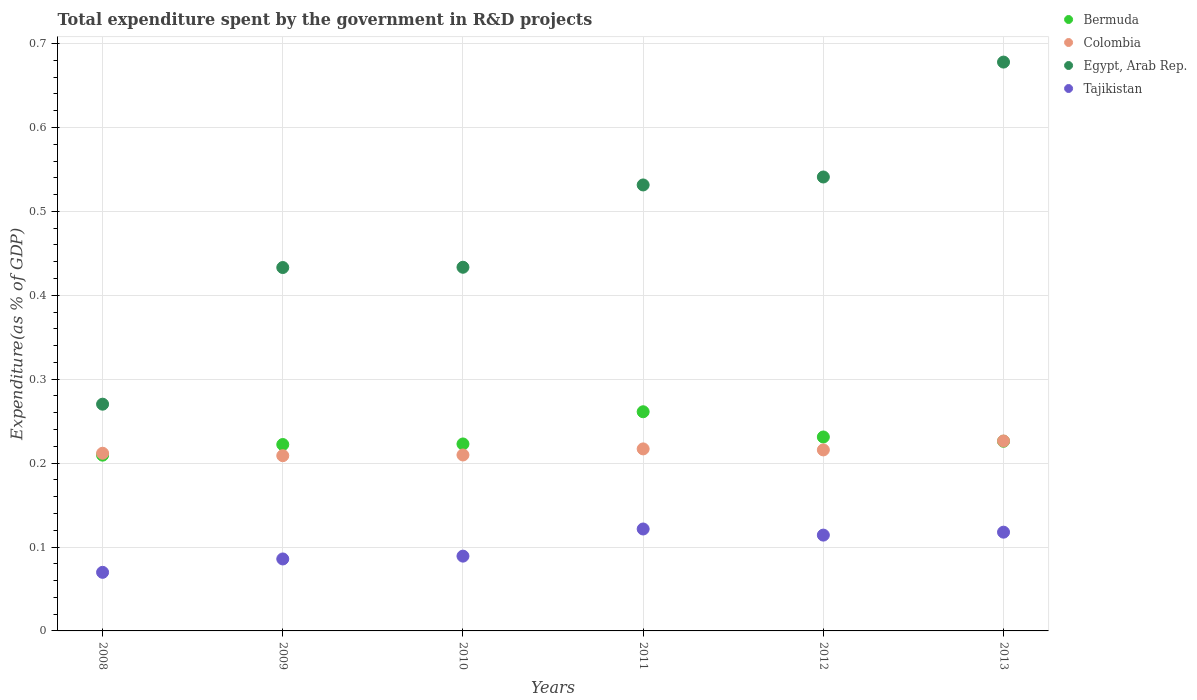What is the total expenditure spent by the government in R&D projects in Tajikistan in 2009?
Give a very brief answer. 0.09. Across all years, what is the maximum total expenditure spent by the government in R&D projects in Egypt, Arab Rep.?
Ensure brevity in your answer.  0.68. Across all years, what is the minimum total expenditure spent by the government in R&D projects in Colombia?
Provide a short and direct response. 0.21. In which year was the total expenditure spent by the government in R&D projects in Tajikistan minimum?
Keep it short and to the point. 2008. What is the total total expenditure spent by the government in R&D projects in Bermuda in the graph?
Keep it short and to the point. 1.37. What is the difference between the total expenditure spent by the government in R&D projects in Tajikistan in 2010 and that in 2011?
Your answer should be very brief. -0.03. What is the difference between the total expenditure spent by the government in R&D projects in Egypt, Arab Rep. in 2010 and the total expenditure spent by the government in R&D projects in Colombia in 2012?
Ensure brevity in your answer.  0.22. What is the average total expenditure spent by the government in R&D projects in Egypt, Arab Rep. per year?
Offer a terse response. 0.48. In the year 2008, what is the difference between the total expenditure spent by the government in R&D projects in Colombia and total expenditure spent by the government in R&D projects in Egypt, Arab Rep.?
Offer a very short reply. -0.06. What is the ratio of the total expenditure spent by the government in R&D projects in Tajikistan in 2011 to that in 2013?
Give a very brief answer. 1.03. Is the difference between the total expenditure spent by the government in R&D projects in Colombia in 2011 and 2013 greater than the difference between the total expenditure spent by the government in R&D projects in Egypt, Arab Rep. in 2011 and 2013?
Give a very brief answer. Yes. What is the difference between the highest and the second highest total expenditure spent by the government in R&D projects in Tajikistan?
Provide a succinct answer. 0. What is the difference between the highest and the lowest total expenditure spent by the government in R&D projects in Bermuda?
Ensure brevity in your answer.  0.05. Is it the case that in every year, the sum of the total expenditure spent by the government in R&D projects in Bermuda and total expenditure spent by the government in R&D projects in Egypt, Arab Rep.  is greater than the sum of total expenditure spent by the government in R&D projects in Tajikistan and total expenditure spent by the government in R&D projects in Colombia?
Offer a terse response. No. Is it the case that in every year, the sum of the total expenditure spent by the government in R&D projects in Colombia and total expenditure spent by the government in R&D projects in Bermuda  is greater than the total expenditure spent by the government in R&D projects in Tajikistan?
Offer a very short reply. Yes. Is the total expenditure spent by the government in R&D projects in Egypt, Arab Rep. strictly greater than the total expenditure spent by the government in R&D projects in Tajikistan over the years?
Your response must be concise. Yes. How many dotlines are there?
Make the answer very short. 4. What is the difference between two consecutive major ticks on the Y-axis?
Your answer should be very brief. 0.1. Are the values on the major ticks of Y-axis written in scientific E-notation?
Your response must be concise. No. Does the graph contain any zero values?
Make the answer very short. No. Where does the legend appear in the graph?
Keep it short and to the point. Top right. How many legend labels are there?
Offer a very short reply. 4. What is the title of the graph?
Provide a succinct answer. Total expenditure spent by the government in R&D projects. What is the label or title of the Y-axis?
Your response must be concise. Expenditure(as % of GDP). What is the Expenditure(as % of GDP) in Bermuda in 2008?
Your response must be concise. 0.21. What is the Expenditure(as % of GDP) in Colombia in 2008?
Offer a very short reply. 0.21. What is the Expenditure(as % of GDP) in Egypt, Arab Rep. in 2008?
Keep it short and to the point. 0.27. What is the Expenditure(as % of GDP) in Tajikistan in 2008?
Your answer should be compact. 0.07. What is the Expenditure(as % of GDP) in Bermuda in 2009?
Offer a terse response. 0.22. What is the Expenditure(as % of GDP) of Colombia in 2009?
Offer a terse response. 0.21. What is the Expenditure(as % of GDP) of Egypt, Arab Rep. in 2009?
Give a very brief answer. 0.43. What is the Expenditure(as % of GDP) of Tajikistan in 2009?
Keep it short and to the point. 0.09. What is the Expenditure(as % of GDP) in Bermuda in 2010?
Offer a terse response. 0.22. What is the Expenditure(as % of GDP) of Colombia in 2010?
Ensure brevity in your answer.  0.21. What is the Expenditure(as % of GDP) of Egypt, Arab Rep. in 2010?
Give a very brief answer. 0.43. What is the Expenditure(as % of GDP) in Tajikistan in 2010?
Offer a terse response. 0.09. What is the Expenditure(as % of GDP) of Bermuda in 2011?
Your answer should be compact. 0.26. What is the Expenditure(as % of GDP) of Colombia in 2011?
Provide a short and direct response. 0.22. What is the Expenditure(as % of GDP) in Egypt, Arab Rep. in 2011?
Make the answer very short. 0.53. What is the Expenditure(as % of GDP) of Tajikistan in 2011?
Give a very brief answer. 0.12. What is the Expenditure(as % of GDP) of Bermuda in 2012?
Offer a very short reply. 0.23. What is the Expenditure(as % of GDP) in Colombia in 2012?
Ensure brevity in your answer.  0.22. What is the Expenditure(as % of GDP) in Egypt, Arab Rep. in 2012?
Your response must be concise. 0.54. What is the Expenditure(as % of GDP) in Tajikistan in 2012?
Ensure brevity in your answer.  0.11. What is the Expenditure(as % of GDP) of Bermuda in 2013?
Give a very brief answer. 0.23. What is the Expenditure(as % of GDP) in Colombia in 2013?
Your response must be concise. 0.23. What is the Expenditure(as % of GDP) of Egypt, Arab Rep. in 2013?
Your response must be concise. 0.68. What is the Expenditure(as % of GDP) in Tajikistan in 2013?
Keep it short and to the point. 0.12. Across all years, what is the maximum Expenditure(as % of GDP) in Bermuda?
Ensure brevity in your answer.  0.26. Across all years, what is the maximum Expenditure(as % of GDP) in Colombia?
Your response must be concise. 0.23. Across all years, what is the maximum Expenditure(as % of GDP) in Egypt, Arab Rep.?
Offer a very short reply. 0.68. Across all years, what is the maximum Expenditure(as % of GDP) in Tajikistan?
Your answer should be compact. 0.12. Across all years, what is the minimum Expenditure(as % of GDP) of Bermuda?
Offer a terse response. 0.21. Across all years, what is the minimum Expenditure(as % of GDP) of Colombia?
Make the answer very short. 0.21. Across all years, what is the minimum Expenditure(as % of GDP) in Egypt, Arab Rep.?
Offer a terse response. 0.27. Across all years, what is the minimum Expenditure(as % of GDP) in Tajikistan?
Give a very brief answer. 0.07. What is the total Expenditure(as % of GDP) of Bermuda in the graph?
Ensure brevity in your answer.  1.37. What is the total Expenditure(as % of GDP) of Colombia in the graph?
Give a very brief answer. 1.29. What is the total Expenditure(as % of GDP) of Egypt, Arab Rep. in the graph?
Provide a succinct answer. 2.89. What is the total Expenditure(as % of GDP) in Tajikistan in the graph?
Make the answer very short. 0.6. What is the difference between the Expenditure(as % of GDP) of Bermuda in 2008 and that in 2009?
Provide a succinct answer. -0.01. What is the difference between the Expenditure(as % of GDP) in Colombia in 2008 and that in 2009?
Your answer should be very brief. 0. What is the difference between the Expenditure(as % of GDP) of Egypt, Arab Rep. in 2008 and that in 2009?
Your answer should be very brief. -0.16. What is the difference between the Expenditure(as % of GDP) in Tajikistan in 2008 and that in 2009?
Make the answer very short. -0.02. What is the difference between the Expenditure(as % of GDP) of Bermuda in 2008 and that in 2010?
Offer a very short reply. -0.01. What is the difference between the Expenditure(as % of GDP) of Colombia in 2008 and that in 2010?
Your answer should be compact. 0. What is the difference between the Expenditure(as % of GDP) of Egypt, Arab Rep. in 2008 and that in 2010?
Offer a very short reply. -0.16. What is the difference between the Expenditure(as % of GDP) of Tajikistan in 2008 and that in 2010?
Make the answer very short. -0.02. What is the difference between the Expenditure(as % of GDP) in Bermuda in 2008 and that in 2011?
Offer a very short reply. -0.05. What is the difference between the Expenditure(as % of GDP) in Colombia in 2008 and that in 2011?
Offer a terse response. -0.01. What is the difference between the Expenditure(as % of GDP) in Egypt, Arab Rep. in 2008 and that in 2011?
Your answer should be compact. -0.26. What is the difference between the Expenditure(as % of GDP) of Tajikistan in 2008 and that in 2011?
Make the answer very short. -0.05. What is the difference between the Expenditure(as % of GDP) in Bermuda in 2008 and that in 2012?
Provide a succinct answer. -0.02. What is the difference between the Expenditure(as % of GDP) of Colombia in 2008 and that in 2012?
Your answer should be compact. -0. What is the difference between the Expenditure(as % of GDP) of Egypt, Arab Rep. in 2008 and that in 2012?
Provide a succinct answer. -0.27. What is the difference between the Expenditure(as % of GDP) in Tajikistan in 2008 and that in 2012?
Give a very brief answer. -0.04. What is the difference between the Expenditure(as % of GDP) of Bermuda in 2008 and that in 2013?
Your answer should be very brief. -0.02. What is the difference between the Expenditure(as % of GDP) of Colombia in 2008 and that in 2013?
Your answer should be compact. -0.01. What is the difference between the Expenditure(as % of GDP) in Egypt, Arab Rep. in 2008 and that in 2013?
Provide a short and direct response. -0.41. What is the difference between the Expenditure(as % of GDP) in Tajikistan in 2008 and that in 2013?
Provide a succinct answer. -0.05. What is the difference between the Expenditure(as % of GDP) in Bermuda in 2009 and that in 2010?
Offer a terse response. -0. What is the difference between the Expenditure(as % of GDP) in Colombia in 2009 and that in 2010?
Ensure brevity in your answer.  -0. What is the difference between the Expenditure(as % of GDP) in Egypt, Arab Rep. in 2009 and that in 2010?
Make the answer very short. -0. What is the difference between the Expenditure(as % of GDP) in Tajikistan in 2009 and that in 2010?
Keep it short and to the point. -0. What is the difference between the Expenditure(as % of GDP) of Bermuda in 2009 and that in 2011?
Give a very brief answer. -0.04. What is the difference between the Expenditure(as % of GDP) in Colombia in 2009 and that in 2011?
Ensure brevity in your answer.  -0.01. What is the difference between the Expenditure(as % of GDP) in Egypt, Arab Rep. in 2009 and that in 2011?
Make the answer very short. -0.1. What is the difference between the Expenditure(as % of GDP) of Tajikistan in 2009 and that in 2011?
Keep it short and to the point. -0.04. What is the difference between the Expenditure(as % of GDP) in Bermuda in 2009 and that in 2012?
Your answer should be very brief. -0.01. What is the difference between the Expenditure(as % of GDP) of Colombia in 2009 and that in 2012?
Offer a very short reply. -0.01. What is the difference between the Expenditure(as % of GDP) in Egypt, Arab Rep. in 2009 and that in 2012?
Offer a very short reply. -0.11. What is the difference between the Expenditure(as % of GDP) of Tajikistan in 2009 and that in 2012?
Keep it short and to the point. -0.03. What is the difference between the Expenditure(as % of GDP) in Bermuda in 2009 and that in 2013?
Your answer should be compact. -0. What is the difference between the Expenditure(as % of GDP) in Colombia in 2009 and that in 2013?
Your answer should be compact. -0.02. What is the difference between the Expenditure(as % of GDP) of Egypt, Arab Rep. in 2009 and that in 2013?
Make the answer very short. -0.24. What is the difference between the Expenditure(as % of GDP) of Tajikistan in 2009 and that in 2013?
Provide a short and direct response. -0.03. What is the difference between the Expenditure(as % of GDP) of Bermuda in 2010 and that in 2011?
Provide a succinct answer. -0.04. What is the difference between the Expenditure(as % of GDP) in Colombia in 2010 and that in 2011?
Ensure brevity in your answer.  -0.01. What is the difference between the Expenditure(as % of GDP) in Egypt, Arab Rep. in 2010 and that in 2011?
Your answer should be compact. -0.1. What is the difference between the Expenditure(as % of GDP) in Tajikistan in 2010 and that in 2011?
Give a very brief answer. -0.03. What is the difference between the Expenditure(as % of GDP) of Bermuda in 2010 and that in 2012?
Your answer should be very brief. -0.01. What is the difference between the Expenditure(as % of GDP) in Colombia in 2010 and that in 2012?
Your answer should be very brief. -0.01. What is the difference between the Expenditure(as % of GDP) in Egypt, Arab Rep. in 2010 and that in 2012?
Your answer should be compact. -0.11. What is the difference between the Expenditure(as % of GDP) in Tajikistan in 2010 and that in 2012?
Offer a terse response. -0.03. What is the difference between the Expenditure(as % of GDP) of Bermuda in 2010 and that in 2013?
Make the answer very short. -0. What is the difference between the Expenditure(as % of GDP) in Colombia in 2010 and that in 2013?
Give a very brief answer. -0.02. What is the difference between the Expenditure(as % of GDP) of Egypt, Arab Rep. in 2010 and that in 2013?
Offer a terse response. -0.24. What is the difference between the Expenditure(as % of GDP) of Tajikistan in 2010 and that in 2013?
Provide a succinct answer. -0.03. What is the difference between the Expenditure(as % of GDP) in Bermuda in 2011 and that in 2012?
Give a very brief answer. 0.03. What is the difference between the Expenditure(as % of GDP) of Colombia in 2011 and that in 2012?
Make the answer very short. 0. What is the difference between the Expenditure(as % of GDP) in Egypt, Arab Rep. in 2011 and that in 2012?
Provide a succinct answer. -0.01. What is the difference between the Expenditure(as % of GDP) in Tajikistan in 2011 and that in 2012?
Your response must be concise. 0.01. What is the difference between the Expenditure(as % of GDP) of Bermuda in 2011 and that in 2013?
Provide a succinct answer. 0.04. What is the difference between the Expenditure(as % of GDP) of Colombia in 2011 and that in 2013?
Keep it short and to the point. -0.01. What is the difference between the Expenditure(as % of GDP) of Egypt, Arab Rep. in 2011 and that in 2013?
Give a very brief answer. -0.15. What is the difference between the Expenditure(as % of GDP) in Tajikistan in 2011 and that in 2013?
Provide a succinct answer. 0. What is the difference between the Expenditure(as % of GDP) of Bermuda in 2012 and that in 2013?
Your response must be concise. 0.01. What is the difference between the Expenditure(as % of GDP) of Colombia in 2012 and that in 2013?
Your answer should be compact. -0.01. What is the difference between the Expenditure(as % of GDP) in Egypt, Arab Rep. in 2012 and that in 2013?
Offer a terse response. -0.14. What is the difference between the Expenditure(as % of GDP) in Tajikistan in 2012 and that in 2013?
Give a very brief answer. -0. What is the difference between the Expenditure(as % of GDP) in Bermuda in 2008 and the Expenditure(as % of GDP) in Colombia in 2009?
Offer a terse response. 0. What is the difference between the Expenditure(as % of GDP) of Bermuda in 2008 and the Expenditure(as % of GDP) of Egypt, Arab Rep. in 2009?
Provide a succinct answer. -0.22. What is the difference between the Expenditure(as % of GDP) of Bermuda in 2008 and the Expenditure(as % of GDP) of Tajikistan in 2009?
Offer a terse response. 0.12. What is the difference between the Expenditure(as % of GDP) of Colombia in 2008 and the Expenditure(as % of GDP) of Egypt, Arab Rep. in 2009?
Keep it short and to the point. -0.22. What is the difference between the Expenditure(as % of GDP) of Colombia in 2008 and the Expenditure(as % of GDP) of Tajikistan in 2009?
Ensure brevity in your answer.  0.13. What is the difference between the Expenditure(as % of GDP) of Egypt, Arab Rep. in 2008 and the Expenditure(as % of GDP) of Tajikistan in 2009?
Your answer should be very brief. 0.18. What is the difference between the Expenditure(as % of GDP) of Bermuda in 2008 and the Expenditure(as % of GDP) of Colombia in 2010?
Make the answer very short. -0. What is the difference between the Expenditure(as % of GDP) in Bermuda in 2008 and the Expenditure(as % of GDP) in Egypt, Arab Rep. in 2010?
Your response must be concise. -0.22. What is the difference between the Expenditure(as % of GDP) of Bermuda in 2008 and the Expenditure(as % of GDP) of Tajikistan in 2010?
Provide a succinct answer. 0.12. What is the difference between the Expenditure(as % of GDP) of Colombia in 2008 and the Expenditure(as % of GDP) of Egypt, Arab Rep. in 2010?
Keep it short and to the point. -0.22. What is the difference between the Expenditure(as % of GDP) in Colombia in 2008 and the Expenditure(as % of GDP) in Tajikistan in 2010?
Provide a succinct answer. 0.12. What is the difference between the Expenditure(as % of GDP) in Egypt, Arab Rep. in 2008 and the Expenditure(as % of GDP) in Tajikistan in 2010?
Offer a very short reply. 0.18. What is the difference between the Expenditure(as % of GDP) in Bermuda in 2008 and the Expenditure(as % of GDP) in Colombia in 2011?
Ensure brevity in your answer.  -0.01. What is the difference between the Expenditure(as % of GDP) in Bermuda in 2008 and the Expenditure(as % of GDP) in Egypt, Arab Rep. in 2011?
Your response must be concise. -0.32. What is the difference between the Expenditure(as % of GDP) of Bermuda in 2008 and the Expenditure(as % of GDP) of Tajikistan in 2011?
Your response must be concise. 0.09. What is the difference between the Expenditure(as % of GDP) of Colombia in 2008 and the Expenditure(as % of GDP) of Egypt, Arab Rep. in 2011?
Offer a very short reply. -0.32. What is the difference between the Expenditure(as % of GDP) of Colombia in 2008 and the Expenditure(as % of GDP) of Tajikistan in 2011?
Your response must be concise. 0.09. What is the difference between the Expenditure(as % of GDP) of Egypt, Arab Rep. in 2008 and the Expenditure(as % of GDP) of Tajikistan in 2011?
Keep it short and to the point. 0.15. What is the difference between the Expenditure(as % of GDP) in Bermuda in 2008 and the Expenditure(as % of GDP) in Colombia in 2012?
Make the answer very short. -0.01. What is the difference between the Expenditure(as % of GDP) of Bermuda in 2008 and the Expenditure(as % of GDP) of Egypt, Arab Rep. in 2012?
Offer a terse response. -0.33. What is the difference between the Expenditure(as % of GDP) in Bermuda in 2008 and the Expenditure(as % of GDP) in Tajikistan in 2012?
Your answer should be compact. 0.1. What is the difference between the Expenditure(as % of GDP) of Colombia in 2008 and the Expenditure(as % of GDP) of Egypt, Arab Rep. in 2012?
Your response must be concise. -0.33. What is the difference between the Expenditure(as % of GDP) in Colombia in 2008 and the Expenditure(as % of GDP) in Tajikistan in 2012?
Provide a succinct answer. 0.1. What is the difference between the Expenditure(as % of GDP) in Egypt, Arab Rep. in 2008 and the Expenditure(as % of GDP) in Tajikistan in 2012?
Make the answer very short. 0.16. What is the difference between the Expenditure(as % of GDP) in Bermuda in 2008 and the Expenditure(as % of GDP) in Colombia in 2013?
Offer a very short reply. -0.02. What is the difference between the Expenditure(as % of GDP) of Bermuda in 2008 and the Expenditure(as % of GDP) of Egypt, Arab Rep. in 2013?
Give a very brief answer. -0.47. What is the difference between the Expenditure(as % of GDP) in Bermuda in 2008 and the Expenditure(as % of GDP) in Tajikistan in 2013?
Your response must be concise. 0.09. What is the difference between the Expenditure(as % of GDP) of Colombia in 2008 and the Expenditure(as % of GDP) of Egypt, Arab Rep. in 2013?
Your response must be concise. -0.47. What is the difference between the Expenditure(as % of GDP) of Colombia in 2008 and the Expenditure(as % of GDP) of Tajikistan in 2013?
Give a very brief answer. 0.09. What is the difference between the Expenditure(as % of GDP) in Egypt, Arab Rep. in 2008 and the Expenditure(as % of GDP) in Tajikistan in 2013?
Your answer should be very brief. 0.15. What is the difference between the Expenditure(as % of GDP) of Bermuda in 2009 and the Expenditure(as % of GDP) of Colombia in 2010?
Your answer should be very brief. 0.01. What is the difference between the Expenditure(as % of GDP) of Bermuda in 2009 and the Expenditure(as % of GDP) of Egypt, Arab Rep. in 2010?
Give a very brief answer. -0.21. What is the difference between the Expenditure(as % of GDP) of Bermuda in 2009 and the Expenditure(as % of GDP) of Tajikistan in 2010?
Your response must be concise. 0.13. What is the difference between the Expenditure(as % of GDP) of Colombia in 2009 and the Expenditure(as % of GDP) of Egypt, Arab Rep. in 2010?
Offer a terse response. -0.22. What is the difference between the Expenditure(as % of GDP) of Colombia in 2009 and the Expenditure(as % of GDP) of Tajikistan in 2010?
Offer a very short reply. 0.12. What is the difference between the Expenditure(as % of GDP) of Egypt, Arab Rep. in 2009 and the Expenditure(as % of GDP) of Tajikistan in 2010?
Make the answer very short. 0.34. What is the difference between the Expenditure(as % of GDP) in Bermuda in 2009 and the Expenditure(as % of GDP) in Colombia in 2011?
Your answer should be very brief. 0.01. What is the difference between the Expenditure(as % of GDP) of Bermuda in 2009 and the Expenditure(as % of GDP) of Egypt, Arab Rep. in 2011?
Keep it short and to the point. -0.31. What is the difference between the Expenditure(as % of GDP) of Bermuda in 2009 and the Expenditure(as % of GDP) of Tajikistan in 2011?
Ensure brevity in your answer.  0.1. What is the difference between the Expenditure(as % of GDP) in Colombia in 2009 and the Expenditure(as % of GDP) in Egypt, Arab Rep. in 2011?
Keep it short and to the point. -0.32. What is the difference between the Expenditure(as % of GDP) of Colombia in 2009 and the Expenditure(as % of GDP) of Tajikistan in 2011?
Keep it short and to the point. 0.09. What is the difference between the Expenditure(as % of GDP) in Egypt, Arab Rep. in 2009 and the Expenditure(as % of GDP) in Tajikistan in 2011?
Make the answer very short. 0.31. What is the difference between the Expenditure(as % of GDP) of Bermuda in 2009 and the Expenditure(as % of GDP) of Colombia in 2012?
Your answer should be very brief. 0.01. What is the difference between the Expenditure(as % of GDP) in Bermuda in 2009 and the Expenditure(as % of GDP) in Egypt, Arab Rep. in 2012?
Offer a very short reply. -0.32. What is the difference between the Expenditure(as % of GDP) of Bermuda in 2009 and the Expenditure(as % of GDP) of Tajikistan in 2012?
Your answer should be very brief. 0.11. What is the difference between the Expenditure(as % of GDP) in Colombia in 2009 and the Expenditure(as % of GDP) in Egypt, Arab Rep. in 2012?
Provide a short and direct response. -0.33. What is the difference between the Expenditure(as % of GDP) of Colombia in 2009 and the Expenditure(as % of GDP) of Tajikistan in 2012?
Keep it short and to the point. 0.09. What is the difference between the Expenditure(as % of GDP) of Egypt, Arab Rep. in 2009 and the Expenditure(as % of GDP) of Tajikistan in 2012?
Provide a short and direct response. 0.32. What is the difference between the Expenditure(as % of GDP) of Bermuda in 2009 and the Expenditure(as % of GDP) of Colombia in 2013?
Offer a very short reply. -0. What is the difference between the Expenditure(as % of GDP) of Bermuda in 2009 and the Expenditure(as % of GDP) of Egypt, Arab Rep. in 2013?
Keep it short and to the point. -0.46. What is the difference between the Expenditure(as % of GDP) of Bermuda in 2009 and the Expenditure(as % of GDP) of Tajikistan in 2013?
Make the answer very short. 0.1. What is the difference between the Expenditure(as % of GDP) in Colombia in 2009 and the Expenditure(as % of GDP) in Egypt, Arab Rep. in 2013?
Keep it short and to the point. -0.47. What is the difference between the Expenditure(as % of GDP) in Colombia in 2009 and the Expenditure(as % of GDP) in Tajikistan in 2013?
Offer a very short reply. 0.09. What is the difference between the Expenditure(as % of GDP) of Egypt, Arab Rep. in 2009 and the Expenditure(as % of GDP) of Tajikistan in 2013?
Provide a short and direct response. 0.32. What is the difference between the Expenditure(as % of GDP) of Bermuda in 2010 and the Expenditure(as % of GDP) of Colombia in 2011?
Ensure brevity in your answer.  0.01. What is the difference between the Expenditure(as % of GDP) in Bermuda in 2010 and the Expenditure(as % of GDP) in Egypt, Arab Rep. in 2011?
Your answer should be compact. -0.31. What is the difference between the Expenditure(as % of GDP) in Bermuda in 2010 and the Expenditure(as % of GDP) in Tajikistan in 2011?
Offer a very short reply. 0.1. What is the difference between the Expenditure(as % of GDP) in Colombia in 2010 and the Expenditure(as % of GDP) in Egypt, Arab Rep. in 2011?
Provide a short and direct response. -0.32. What is the difference between the Expenditure(as % of GDP) in Colombia in 2010 and the Expenditure(as % of GDP) in Tajikistan in 2011?
Provide a succinct answer. 0.09. What is the difference between the Expenditure(as % of GDP) in Egypt, Arab Rep. in 2010 and the Expenditure(as % of GDP) in Tajikistan in 2011?
Provide a succinct answer. 0.31. What is the difference between the Expenditure(as % of GDP) of Bermuda in 2010 and the Expenditure(as % of GDP) of Colombia in 2012?
Give a very brief answer. 0.01. What is the difference between the Expenditure(as % of GDP) of Bermuda in 2010 and the Expenditure(as % of GDP) of Egypt, Arab Rep. in 2012?
Your answer should be very brief. -0.32. What is the difference between the Expenditure(as % of GDP) in Bermuda in 2010 and the Expenditure(as % of GDP) in Tajikistan in 2012?
Your response must be concise. 0.11. What is the difference between the Expenditure(as % of GDP) in Colombia in 2010 and the Expenditure(as % of GDP) in Egypt, Arab Rep. in 2012?
Keep it short and to the point. -0.33. What is the difference between the Expenditure(as % of GDP) of Colombia in 2010 and the Expenditure(as % of GDP) of Tajikistan in 2012?
Make the answer very short. 0.1. What is the difference between the Expenditure(as % of GDP) of Egypt, Arab Rep. in 2010 and the Expenditure(as % of GDP) of Tajikistan in 2012?
Your answer should be compact. 0.32. What is the difference between the Expenditure(as % of GDP) in Bermuda in 2010 and the Expenditure(as % of GDP) in Colombia in 2013?
Keep it short and to the point. -0. What is the difference between the Expenditure(as % of GDP) of Bermuda in 2010 and the Expenditure(as % of GDP) of Egypt, Arab Rep. in 2013?
Offer a terse response. -0.46. What is the difference between the Expenditure(as % of GDP) of Bermuda in 2010 and the Expenditure(as % of GDP) of Tajikistan in 2013?
Your answer should be compact. 0.11. What is the difference between the Expenditure(as % of GDP) of Colombia in 2010 and the Expenditure(as % of GDP) of Egypt, Arab Rep. in 2013?
Offer a terse response. -0.47. What is the difference between the Expenditure(as % of GDP) in Colombia in 2010 and the Expenditure(as % of GDP) in Tajikistan in 2013?
Offer a terse response. 0.09. What is the difference between the Expenditure(as % of GDP) of Egypt, Arab Rep. in 2010 and the Expenditure(as % of GDP) of Tajikistan in 2013?
Provide a short and direct response. 0.32. What is the difference between the Expenditure(as % of GDP) of Bermuda in 2011 and the Expenditure(as % of GDP) of Colombia in 2012?
Offer a terse response. 0.05. What is the difference between the Expenditure(as % of GDP) in Bermuda in 2011 and the Expenditure(as % of GDP) in Egypt, Arab Rep. in 2012?
Your answer should be compact. -0.28. What is the difference between the Expenditure(as % of GDP) in Bermuda in 2011 and the Expenditure(as % of GDP) in Tajikistan in 2012?
Offer a terse response. 0.15. What is the difference between the Expenditure(as % of GDP) of Colombia in 2011 and the Expenditure(as % of GDP) of Egypt, Arab Rep. in 2012?
Your answer should be compact. -0.32. What is the difference between the Expenditure(as % of GDP) of Colombia in 2011 and the Expenditure(as % of GDP) of Tajikistan in 2012?
Make the answer very short. 0.1. What is the difference between the Expenditure(as % of GDP) in Egypt, Arab Rep. in 2011 and the Expenditure(as % of GDP) in Tajikistan in 2012?
Provide a short and direct response. 0.42. What is the difference between the Expenditure(as % of GDP) of Bermuda in 2011 and the Expenditure(as % of GDP) of Colombia in 2013?
Ensure brevity in your answer.  0.03. What is the difference between the Expenditure(as % of GDP) in Bermuda in 2011 and the Expenditure(as % of GDP) in Egypt, Arab Rep. in 2013?
Ensure brevity in your answer.  -0.42. What is the difference between the Expenditure(as % of GDP) of Bermuda in 2011 and the Expenditure(as % of GDP) of Tajikistan in 2013?
Give a very brief answer. 0.14. What is the difference between the Expenditure(as % of GDP) in Colombia in 2011 and the Expenditure(as % of GDP) in Egypt, Arab Rep. in 2013?
Provide a short and direct response. -0.46. What is the difference between the Expenditure(as % of GDP) of Colombia in 2011 and the Expenditure(as % of GDP) of Tajikistan in 2013?
Your answer should be very brief. 0.1. What is the difference between the Expenditure(as % of GDP) in Egypt, Arab Rep. in 2011 and the Expenditure(as % of GDP) in Tajikistan in 2013?
Your answer should be compact. 0.41. What is the difference between the Expenditure(as % of GDP) in Bermuda in 2012 and the Expenditure(as % of GDP) in Colombia in 2013?
Ensure brevity in your answer.  0. What is the difference between the Expenditure(as % of GDP) of Bermuda in 2012 and the Expenditure(as % of GDP) of Egypt, Arab Rep. in 2013?
Your answer should be very brief. -0.45. What is the difference between the Expenditure(as % of GDP) in Bermuda in 2012 and the Expenditure(as % of GDP) in Tajikistan in 2013?
Offer a very short reply. 0.11. What is the difference between the Expenditure(as % of GDP) in Colombia in 2012 and the Expenditure(as % of GDP) in Egypt, Arab Rep. in 2013?
Provide a short and direct response. -0.46. What is the difference between the Expenditure(as % of GDP) in Colombia in 2012 and the Expenditure(as % of GDP) in Tajikistan in 2013?
Ensure brevity in your answer.  0.1. What is the difference between the Expenditure(as % of GDP) of Egypt, Arab Rep. in 2012 and the Expenditure(as % of GDP) of Tajikistan in 2013?
Your answer should be compact. 0.42. What is the average Expenditure(as % of GDP) in Bermuda per year?
Give a very brief answer. 0.23. What is the average Expenditure(as % of GDP) of Colombia per year?
Offer a very short reply. 0.21. What is the average Expenditure(as % of GDP) in Egypt, Arab Rep. per year?
Offer a terse response. 0.48. What is the average Expenditure(as % of GDP) of Tajikistan per year?
Give a very brief answer. 0.1. In the year 2008, what is the difference between the Expenditure(as % of GDP) in Bermuda and Expenditure(as % of GDP) in Colombia?
Your response must be concise. -0. In the year 2008, what is the difference between the Expenditure(as % of GDP) of Bermuda and Expenditure(as % of GDP) of Egypt, Arab Rep.?
Your response must be concise. -0.06. In the year 2008, what is the difference between the Expenditure(as % of GDP) of Bermuda and Expenditure(as % of GDP) of Tajikistan?
Provide a short and direct response. 0.14. In the year 2008, what is the difference between the Expenditure(as % of GDP) in Colombia and Expenditure(as % of GDP) in Egypt, Arab Rep.?
Your response must be concise. -0.06. In the year 2008, what is the difference between the Expenditure(as % of GDP) of Colombia and Expenditure(as % of GDP) of Tajikistan?
Provide a succinct answer. 0.14. In the year 2008, what is the difference between the Expenditure(as % of GDP) in Egypt, Arab Rep. and Expenditure(as % of GDP) in Tajikistan?
Your response must be concise. 0.2. In the year 2009, what is the difference between the Expenditure(as % of GDP) in Bermuda and Expenditure(as % of GDP) in Colombia?
Provide a short and direct response. 0.01. In the year 2009, what is the difference between the Expenditure(as % of GDP) in Bermuda and Expenditure(as % of GDP) in Egypt, Arab Rep.?
Offer a terse response. -0.21. In the year 2009, what is the difference between the Expenditure(as % of GDP) of Bermuda and Expenditure(as % of GDP) of Tajikistan?
Provide a succinct answer. 0.14. In the year 2009, what is the difference between the Expenditure(as % of GDP) in Colombia and Expenditure(as % of GDP) in Egypt, Arab Rep.?
Your answer should be compact. -0.22. In the year 2009, what is the difference between the Expenditure(as % of GDP) in Colombia and Expenditure(as % of GDP) in Tajikistan?
Provide a short and direct response. 0.12. In the year 2009, what is the difference between the Expenditure(as % of GDP) in Egypt, Arab Rep. and Expenditure(as % of GDP) in Tajikistan?
Your answer should be very brief. 0.35. In the year 2010, what is the difference between the Expenditure(as % of GDP) in Bermuda and Expenditure(as % of GDP) in Colombia?
Make the answer very short. 0.01. In the year 2010, what is the difference between the Expenditure(as % of GDP) in Bermuda and Expenditure(as % of GDP) in Egypt, Arab Rep.?
Ensure brevity in your answer.  -0.21. In the year 2010, what is the difference between the Expenditure(as % of GDP) in Bermuda and Expenditure(as % of GDP) in Tajikistan?
Ensure brevity in your answer.  0.13. In the year 2010, what is the difference between the Expenditure(as % of GDP) in Colombia and Expenditure(as % of GDP) in Egypt, Arab Rep.?
Your answer should be compact. -0.22. In the year 2010, what is the difference between the Expenditure(as % of GDP) of Colombia and Expenditure(as % of GDP) of Tajikistan?
Your answer should be very brief. 0.12. In the year 2010, what is the difference between the Expenditure(as % of GDP) of Egypt, Arab Rep. and Expenditure(as % of GDP) of Tajikistan?
Provide a short and direct response. 0.34. In the year 2011, what is the difference between the Expenditure(as % of GDP) of Bermuda and Expenditure(as % of GDP) of Colombia?
Your answer should be compact. 0.04. In the year 2011, what is the difference between the Expenditure(as % of GDP) in Bermuda and Expenditure(as % of GDP) in Egypt, Arab Rep.?
Ensure brevity in your answer.  -0.27. In the year 2011, what is the difference between the Expenditure(as % of GDP) of Bermuda and Expenditure(as % of GDP) of Tajikistan?
Your response must be concise. 0.14. In the year 2011, what is the difference between the Expenditure(as % of GDP) of Colombia and Expenditure(as % of GDP) of Egypt, Arab Rep.?
Offer a terse response. -0.31. In the year 2011, what is the difference between the Expenditure(as % of GDP) in Colombia and Expenditure(as % of GDP) in Tajikistan?
Provide a short and direct response. 0.1. In the year 2011, what is the difference between the Expenditure(as % of GDP) in Egypt, Arab Rep. and Expenditure(as % of GDP) in Tajikistan?
Provide a succinct answer. 0.41. In the year 2012, what is the difference between the Expenditure(as % of GDP) of Bermuda and Expenditure(as % of GDP) of Colombia?
Make the answer very short. 0.02. In the year 2012, what is the difference between the Expenditure(as % of GDP) of Bermuda and Expenditure(as % of GDP) of Egypt, Arab Rep.?
Keep it short and to the point. -0.31. In the year 2012, what is the difference between the Expenditure(as % of GDP) of Bermuda and Expenditure(as % of GDP) of Tajikistan?
Your answer should be very brief. 0.12. In the year 2012, what is the difference between the Expenditure(as % of GDP) of Colombia and Expenditure(as % of GDP) of Egypt, Arab Rep.?
Your answer should be compact. -0.33. In the year 2012, what is the difference between the Expenditure(as % of GDP) of Colombia and Expenditure(as % of GDP) of Tajikistan?
Offer a terse response. 0.1. In the year 2012, what is the difference between the Expenditure(as % of GDP) in Egypt, Arab Rep. and Expenditure(as % of GDP) in Tajikistan?
Your answer should be compact. 0.43. In the year 2013, what is the difference between the Expenditure(as % of GDP) in Bermuda and Expenditure(as % of GDP) in Colombia?
Provide a short and direct response. -0. In the year 2013, what is the difference between the Expenditure(as % of GDP) in Bermuda and Expenditure(as % of GDP) in Egypt, Arab Rep.?
Ensure brevity in your answer.  -0.45. In the year 2013, what is the difference between the Expenditure(as % of GDP) of Bermuda and Expenditure(as % of GDP) of Tajikistan?
Offer a very short reply. 0.11. In the year 2013, what is the difference between the Expenditure(as % of GDP) in Colombia and Expenditure(as % of GDP) in Egypt, Arab Rep.?
Give a very brief answer. -0.45. In the year 2013, what is the difference between the Expenditure(as % of GDP) of Colombia and Expenditure(as % of GDP) of Tajikistan?
Keep it short and to the point. 0.11. In the year 2013, what is the difference between the Expenditure(as % of GDP) of Egypt, Arab Rep. and Expenditure(as % of GDP) of Tajikistan?
Your answer should be very brief. 0.56. What is the ratio of the Expenditure(as % of GDP) in Bermuda in 2008 to that in 2009?
Keep it short and to the point. 0.94. What is the ratio of the Expenditure(as % of GDP) in Colombia in 2008 to that in 2009?
Offer a very short reply. 1.01. What is the ratio of the Expenditure(as % of GDP) in Egypt, Arab Rep. in 2008 to that in 2009?
Make the answer very short. 0.62. What is the ratio of the Expenditure(as % of GDP) in Tajikistan in 2008 to that in 2009?
Provide a short and direct response. 0.81. What is the ratio of the Expenditure(as % of GDP) in Bermuda in 2008 to that in 2010?
Make the answer very short. 0.94. What is the ratio of the Expenditure(as % of GDP) of Colombia in 2008 to that in 2010?
Offer a very short reply. 1.01. What is the ratio of the Expenditure(as % of GDP) of Egypt, Arab Rep. in 2008 to that in 2010?
Provide a succinct answer. 0.62. What is the ratio of the Expenditure(as % of GDP) of Tajikistan in 2008 to that in 2010?
Make the answer very short. 0.78. What is the ratio of the Expenditure(as % of GDP) of Bermuda in 2008 to that in 2011?
Provide a succinct answer. 0.8. What is the ratio of the Expenditure(as % of GDP) in Colombia in 2008 to that in 2011?
Your answer should be compact. 0.98. What is the ratio of the Expenditure(as % of GDP) of Egypt, Arab Rep. in 2008 to that in 2011?
Your response must be concise. 0.51. What is the ratio of the Expenditure(as % of GDP) of Tajikistan in 2008 to that in 2011?
Provide a succinct answer. 0.57. What is the ratio of the Expenditure(as % of GDP) in Bermuda in 2008 to that in 2012?
Your answer should be very brief. 0.91. What is the ratio of the Expenditure(as % of GDP) in Colombia in 2008 to that in 2012?
Give a very brief answer. 0.98. What is the ratio of the Expenditure(as % of GDP) of Egypt, Arab Rep. in 2008 to that in 2012?
Ensure brevity in your answer.  0.5. What is the ratio of the Expenditure(as % of GDP) of Tajikistan in 2008 to that in 2012?
Offer a very short reply. 0.61. What is the ratio of the Expenditure(as % of GDP) in Bermuda in 2008 to that in 2013?
Make the answer very short. 0.93. What is the ratio of the Expenditure(as % of GDP) of Colombia in 2008 to that in 2013?
Offer a terse response. 0.94. What is the ratio of the Expenditure(as % of GDP) in Egypt, Arab Rep. in 2008 to that in 2013?
Offer a very short reply. 0.4. What is the ratio of the Expenditure(as % of GDP) of Tajikistan in 2008 to that in 2013?
Ensure brevity in your answer.  0.59. What is the ratio of the Expenditure(as % of GDP) of Bermuda in 2009 to that in 2010?
Make the answer very short. 1. What is the ratio of the Expenditure(as % of GDP) of Colombia in 2009 to that in 2010?
Ensure brevity in your answer.  1. What is the ratio of the Expenditure(as % of GDP) of Egypt, Arab Rep. in 2009 to that in 2010?
Offer a very short reply. 1. What is the ratio of the Expenditure(as % of GDP) of Tajikistan in 2009 to that in 2010?
Your answer should be very brief. 0.96. What is the ratio of the Expenditure(as % of GDP) of Bermuda in 2009 to that in 2011?
Ensure brevity in your answer.  0.85. What is the ratio of the Expenditure(as % of GDP) of Colombia in 2009 to that in 2011?
Provide a succinct answer. 0.96. What is the ratio of the Expenditure(as % of GDP) of Egypt, Arab Rep. in 2009 to that in 2011?
Give a very brief answer. 0.81. What is the ratio of the Expenditure(as % of GDP) of Tajikistan in 2009 to that in 2011?
Make the answer very short. 0.71. What is the ratio of the Expenditure(as % of GDP) in Bermuda in 2009 to that in 2012?
Offer a very short reply. 0.96. What is the ratio of the Expenditure(as % of GDP) in Colombia in 2009 to that in 2012?
Keep it short and to the point. 0.97. What is the ratio of the Expenditure(as % of GDP) of Egypt, Arab Rep. in 2009 to that in 2012?
Your answer should be compact. 0.8. What is the ratio of the Expenditure(as % of GDP) in Tajikistan in 2009 to that in 2012?
Your response must be concise. 0.75. What is the ratio of the Expenditure(as % of GDP) of Bermuda in 2009 to that in 2013?
Give a very brief answer. 0.98. What is the ratio of the Expenditure(as % of GDP) in Colombia in 2009 to that in 2013?
Provide a short and direct response. 0.92. What is the ratio of the Expenditure(as % of GDP) of Egypt, Arab Rep. in 2009 to that in 2013?
Your answer should be very brief. 0.64. What is the ratio of the Expenditure(as % of GDP) of Tajikistan in 2009 to that in 2013?
Provide a succinct answer. 0.73. What is the ratio of the Expenditure(as % of GDP) in Bermuda in 2010 to that in 2011?
Provide a short and direct response. 0.85. What is the ratio of the Expenditure(as % of GDP) in Colombia in 2010 to that in 2011?
Your answer should be compact. 0.97. What is the ratio of the Expenditure(as % of GDP) of Egypt, Arab Rep. in 2010 to that in 2011?
Offer a very short reply. 0.82. What is the ratio of the Expenditure(as % of GDP) of Tajikistan in 2010 to that in 2011?
Your answer should be very brief. 0.73. What is the ratio of the Expenditure(as % of GDP) of Egypt, Arab Rep. in 2010 to that in 2012?
Your response must be concise. 0.8. What is the ratio of the Expenditure(as % of GDP) of Tajikistan in 2010 to that in 2012?
Provide a short and direct response. 0.78. What is the ratio of the Expenditure(as % of GDP) of Bermuda in 2010 to that in 2013?
Offer a very short reply. 0.99. What is the ratio of the Expenditure(as % of GDP) of Colombia in 2010 to that in 2013?
Your answer should be compact. 0.93. What is the ratio of the Expenditure(as % of GDP) in Egypt, Arab Rep. in 2010 to that in 2013?
Keep it short and to the point. 0.64. What is the ratio of the Expenditure(as % of GDP) in Tajikistan in 2010 to that in 2013?
Give a very brief answer. 0.76. What is the ratio of the Expenditure(as % of GDP) of Bermuda in 2011 to that in 2012?
Make the answer very short. 1.13. What is the ratio of the Expenditure(as % of GDP) of Colombia in 2011 to that in 2012?
Offer a terse response. 1.01. What is the ratio of the Expenditure(as % of GDP) in Egypt, Arab Rep. in 2011 to that in 2012?
Offer a very short reply. 0.98. What is the ratio of the Expenditure(as % of GDP) in Tajikistan in 2011 to that in 2012?
Your response must be concise. 1.06. What is the ratio of the Expenditure(as % of GDP) of Bermuda in 2011 to that in 2013?
Give a very brief answer. 1.16. What is the ratio of the Expenditure(as % of GDP) in Colombia in 2011 to that in 2013?
Offer a terse response. 0.96. What is the ratio of the Expenditure(as % of GDP) of Egypt, Arab Rep. in 2011 to that in 2013?
Provide a short and direct response. 0.78. What is the ratio of the Expenditure(as % of GDP) of Tajikistan in 2011 to that in 2013?
Offer a terse response. 1.03. What is the ratio of the Expenditure(as % of GDP) of Bermuda in 2012 to that in 2013?
Offer a very short reply. 1.02. What is the ratio of the Expenditure(as % of GDP) in Colombia in 2012 to that in 2013?
Provide a short and direct response. 0.95. What is the ratio of the Expenditure(as % of GDP) of Egypt, Arab Rep. in 2012 to that in 2013?
Provide a succinct answer. 0.8. What is the ratio of the Expenditure(as % of GDP) of Tajikistan in 2012 to that in 2013?
Provide a short and direct response. 0.97. What is the difference between the highest and the second highest Expenditure(as % of GDP) of Bermuda?
Provide a short and direct response. 0.03. What is the difference between the highest and the second highest Expenditure(as % of GDP) in Colombia?
Ensure brevity in your answer.  0.01. What is the difference between the highest and the second highest Expenditure(as % of GDP) in Egypt, Arab Rep.?
Ensure brevity in your answer.  0.14. What is the difference between the highest and the second highest Expenditure(as % of GDP) of Tajikistan?
Provide a succinct answer. 0. What is the difference between the highest and the lowest Expenditure(as % of GDP) in Bermuda?
Ensure brevity in your answer.  0.05. What is the difference between the highest and the lowest Expenditure(as % of GDP) in Colombia?
Keep it short and to the point. 0.02. What is the difference between the highest and the lowest Expenditure(as % of GDP) of Egypt, Arab Rep.?
Give a very brief answer. 0.41. What is the difference between the highest and the lowest Expenditure(as % of GDP) in Tajikistan?
Your answer should be very brief. 0.05. 